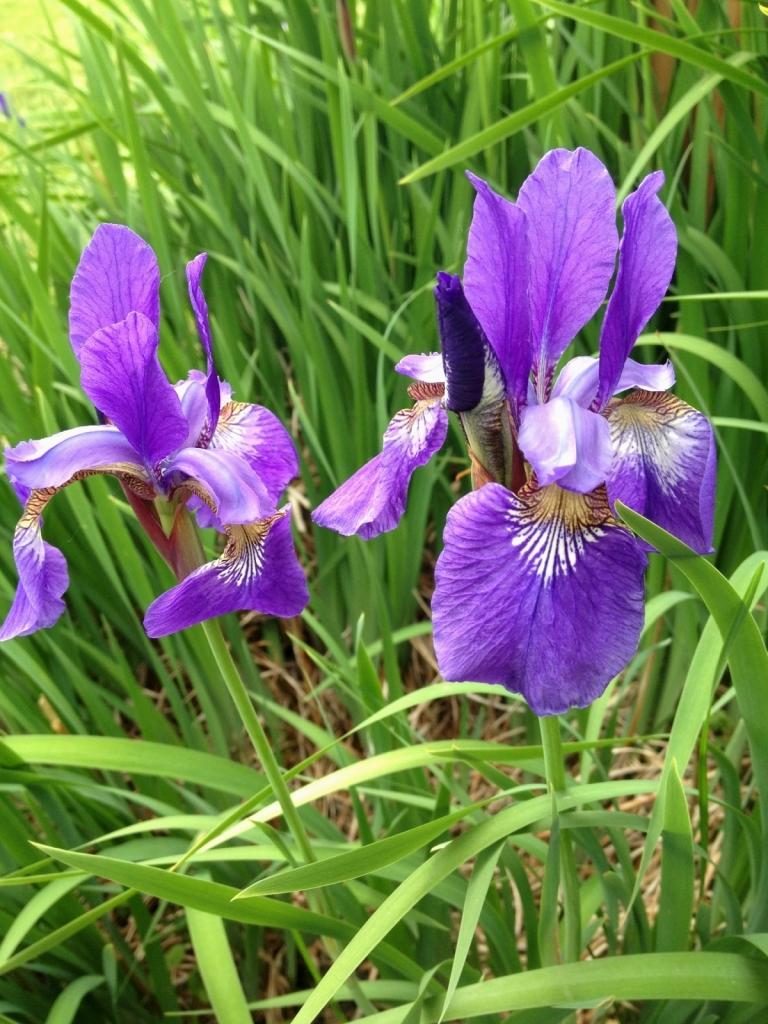What type of plants can be seen in the image? There are flowers in the image. What else can be seen in the image besides flowers? There is grass in the image. What color crayon is used to draw the flowers in the image? There is no crayon or drawing present in the image; it features real flowers and grass. What type of home is depicted in the image? There is no home depicted in the image; it only shows flowers and grass. 